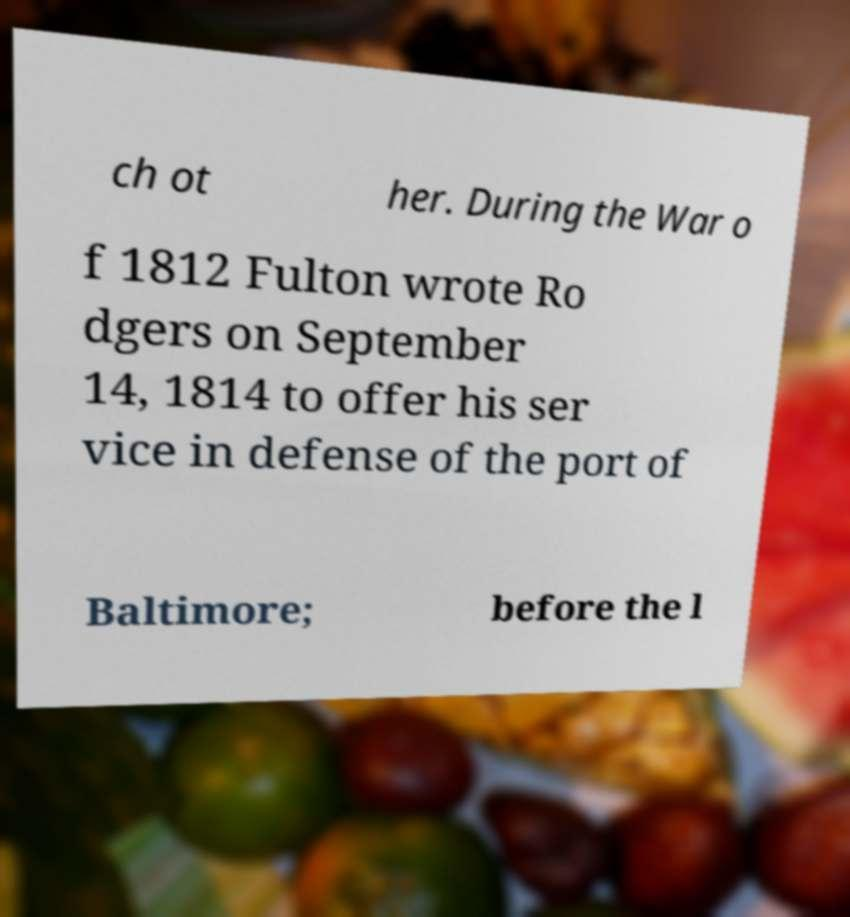Can you read and provide the text displayed in the image?This photo seems to have some interesting text. Can you extract and type it out for me? ch ot her. During the War o f 1812 Fulton wrote Ro dgers on September 14, 1814 to offer his ser vice in defense of the port of Baltimore; before the l 